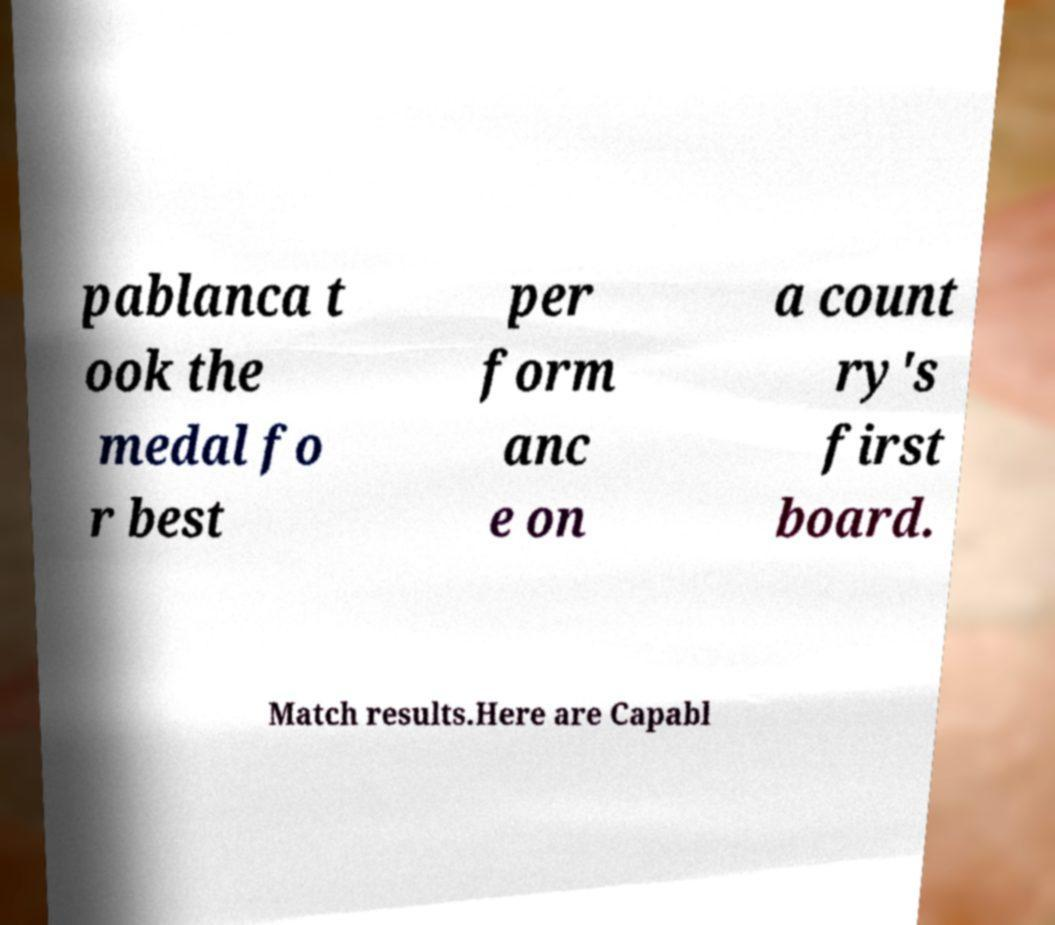Can you accurately transcribe the text from the provided image for me? pablanca t ook the medal fo r best per form anc e on a count ry's first board. Match results.Here are Capabl 